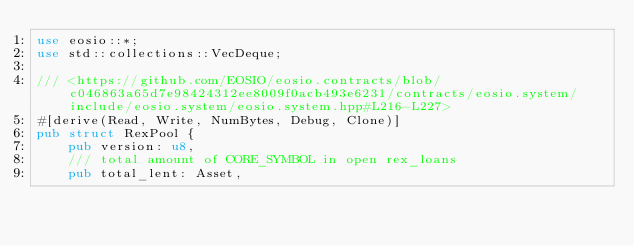Convert code to text. <code><loc_0><loc_0><loc_500><loc_500><_Rust_>use eosio::*;
use std::collections::VecDeque;

/// <https://github.com/EOSIO/eosio.contracts/blob/c046863a65d7e98424312ee8009f0acb493e6231/contracts/eosio.system/include/eosio.system/eosio.system.hpp#L216-L227>
#[derive(Read, Write, NumBytes, Debug, Clone)]
pub struct RexPool {
    pub version: u8,
    /// total amount of CORE_SYMBOL in open rex_loans
    pub total_lent: Asset,</code> 